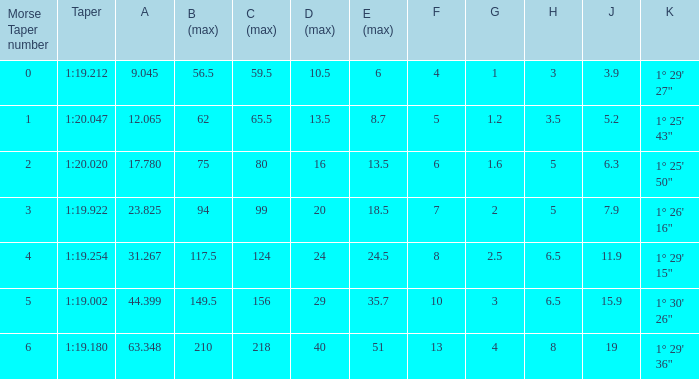What is the value of h when the maximum value of c is 99? 5.0. Can you give me this table as a dict? {'header': ['Morse Taper number', 'Taper', 'A', 'B (max)', 'C (max)', 'D (max)', 'E (max)', 'F', 'G', 'H', 'J', 'K'], 'rows': [['0', '1:19.212', '9.045', '56.5', '59.5', '10.5', '6', '4', '1', '3', '3.9', '1° 29\' 27"'], ['1', '1:20.047', '12.065', '62', '65.5', '13.5', '8.7', '5', '1.2', '3.5', '5.2', '1° 25\' 43"'], ['2', '1:20.020', '17.780', '75', '80', '16', '13.5', '6', '1.6', '5', '6.3', '1° 25\' 50"'], ['3', '1:19.922', '23.825', '94', '99', '20', '18.5', '7', '2', '5', '7.9', '1° 26\' 16"'], ['4', '1:19.254', '31.267', '117.5', '124', '24', '24.5', '8', '2.5', '6.5', '11.9', '1° 29\' 15"'], ['5', '1:19.002', '44.399', '149.5', '156', '29', '35.7', '10', '3', '6.5', '15.9', '1° 30\' 26"'], ['6', '1:19.180', '63.348', '210', '218', '40', '51', '13', '4', '8', '19', '1° 29\' 36"']]} 